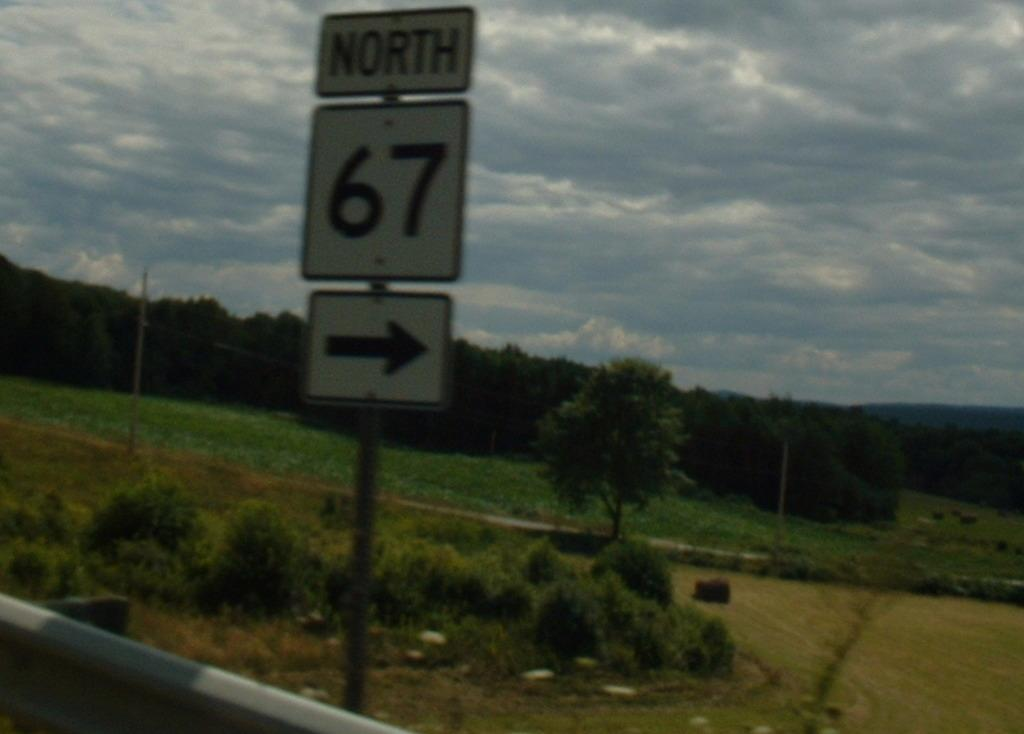<image>
Render a clear and concise summary of the photo. A road sign pointing north to highway 67 is on the side of the road, in front of open land. 